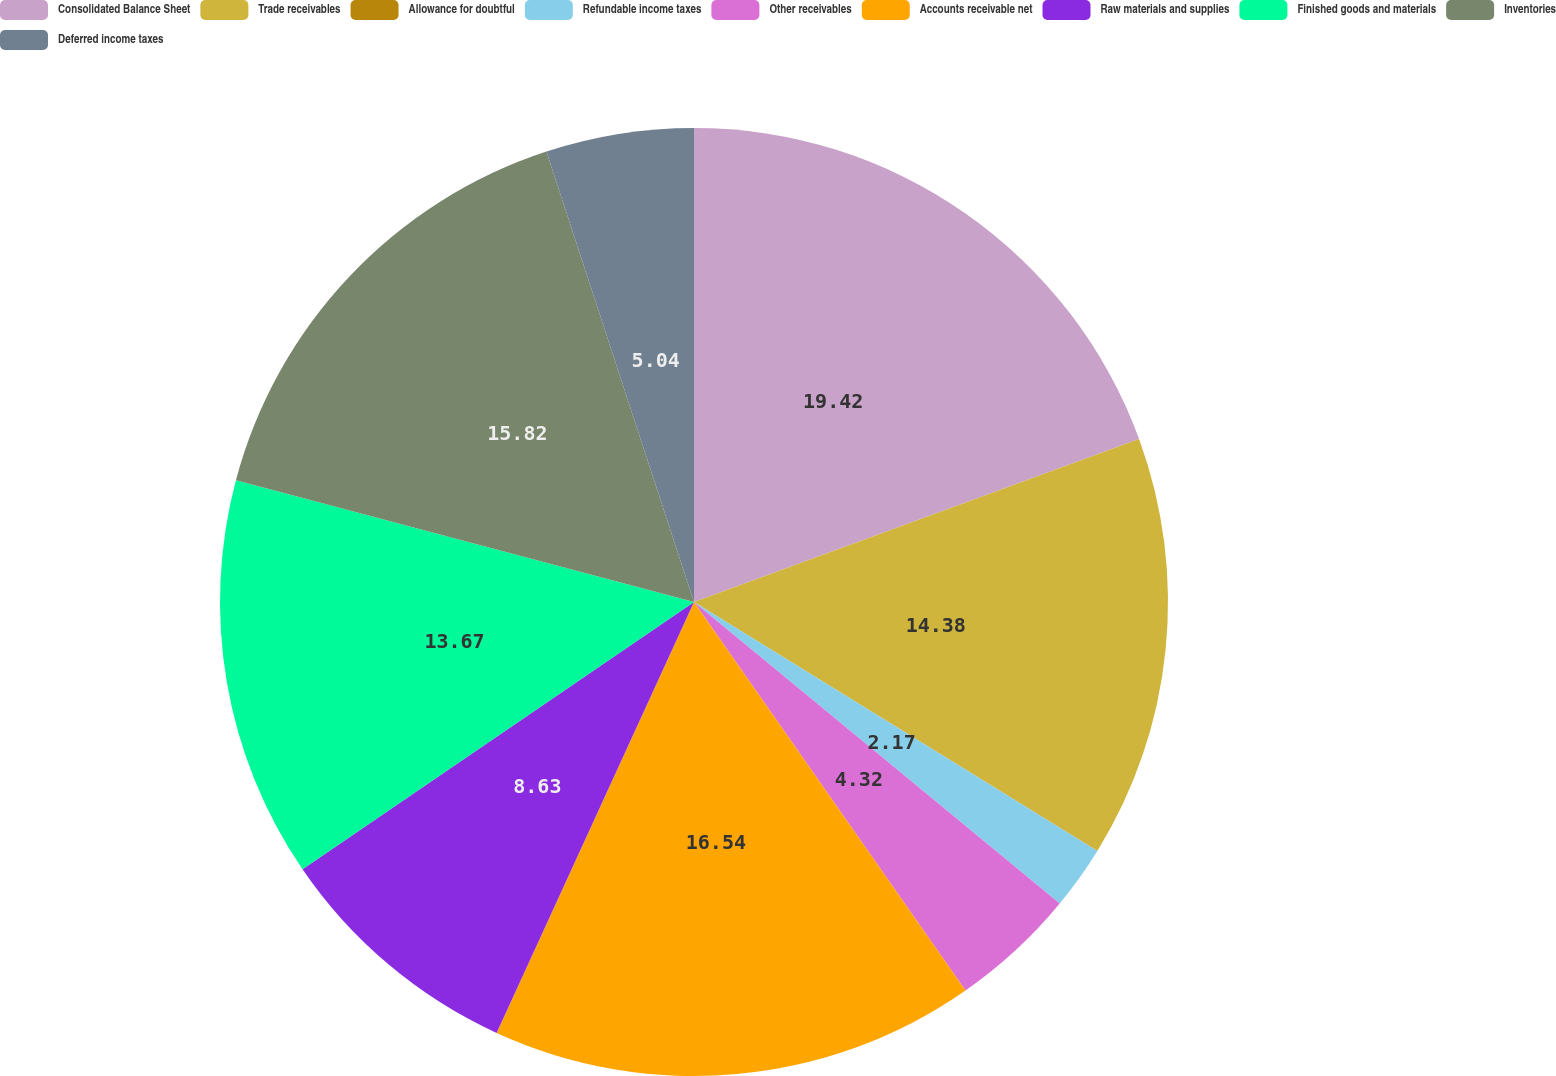<chart> <loc_0><loc_0><loc_500><loc_500><pie_chart><fcel>Consolidated Balance Sheet<fcel>Trade receivables<fcel>Allowance for doubtful<fcel>Refundable income taxes<fcel>Other receivables<fcel>Accounts receivable net<fcel>Raw materials and supplies<fcel>Finished goods and materials<fcel>Inventories<fcel>Deferred income taxes<nl><fcel>19.41%<fcel>14.38%<fcel>0.01%<fcel>2.17%<fcel>4.32%<fcel>16.54%<fcel>8.63%<fcel>13.67%<fcel>15.82%<fcel>5.04%<nl></chart> 